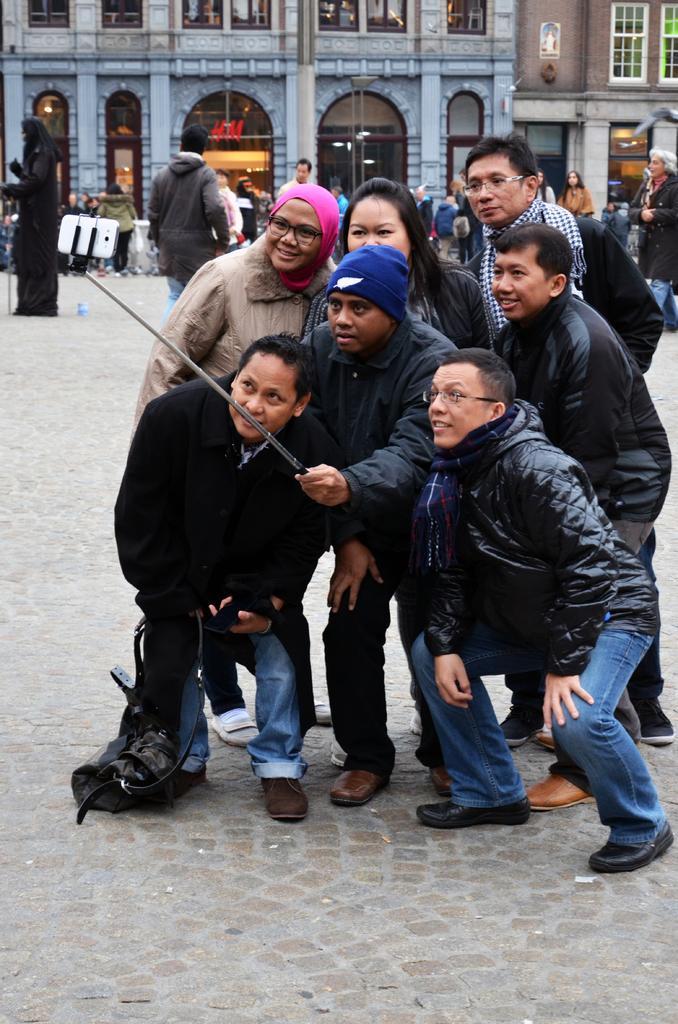Can you describe this image briefly? In the image there are few people in jackets standing on the road taking picture in a cell phone with the aid of selfie stick, in the back there are buildings with people walking in front of it. 